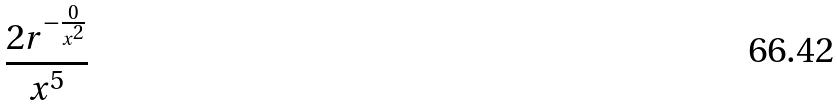Convert formula to latex. <formula><loc_0><loc_0><loc_500><loc_500>\frac { 2 r ^ { - \frac { 0 } { x ^ { 2 } } } } { x ^ { 5 } }</formula> 